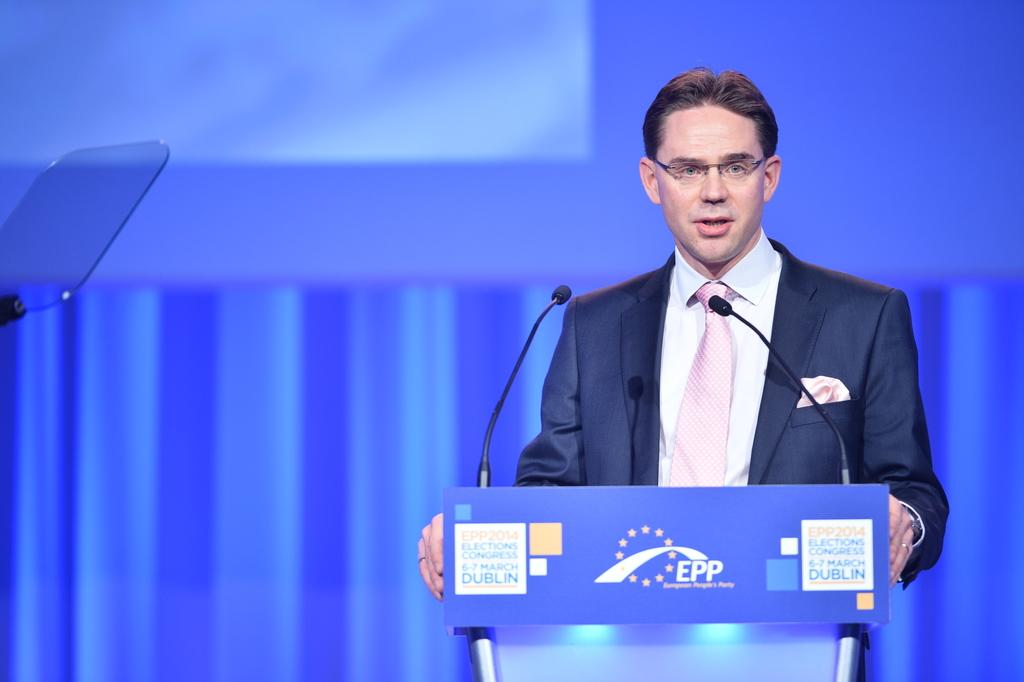What is the man in the image wearing? The man is wearing spectacles, a blazer, and a tie. What is the man doing in the image? The man is standing at a podium. What is in front of the man at the podium? There are microphones in front of the man. What can be seen in the background of the image? There is an object and a wall in the background of the image. What type of pie is the man eating in the image? There is no pie present in the image; the man is standing at a podium with microphones in front of him. 